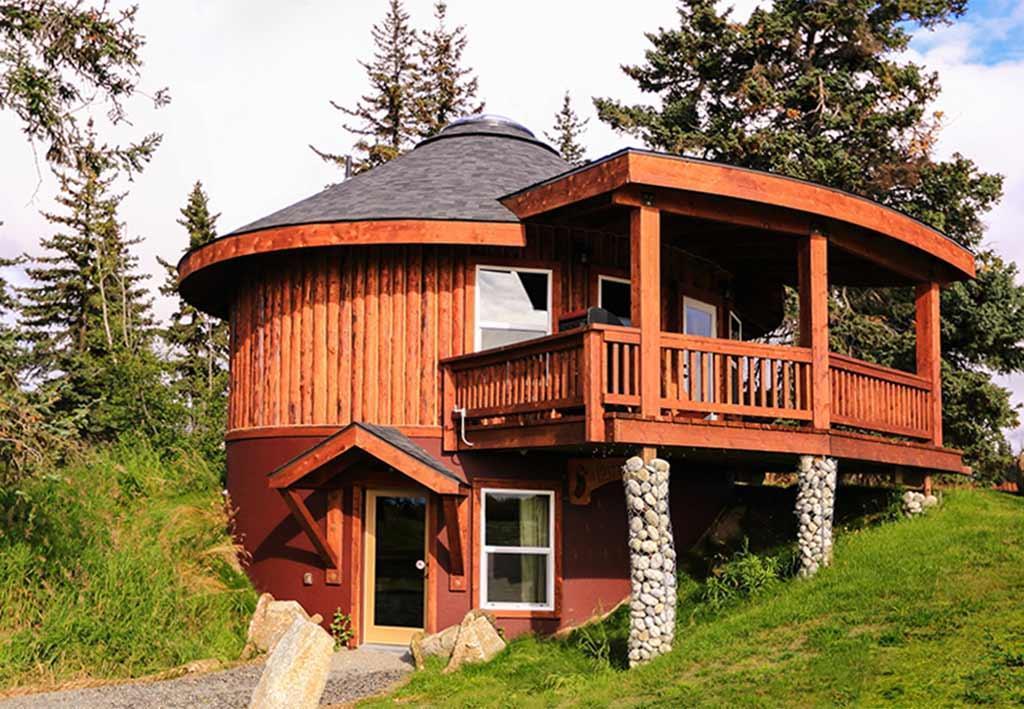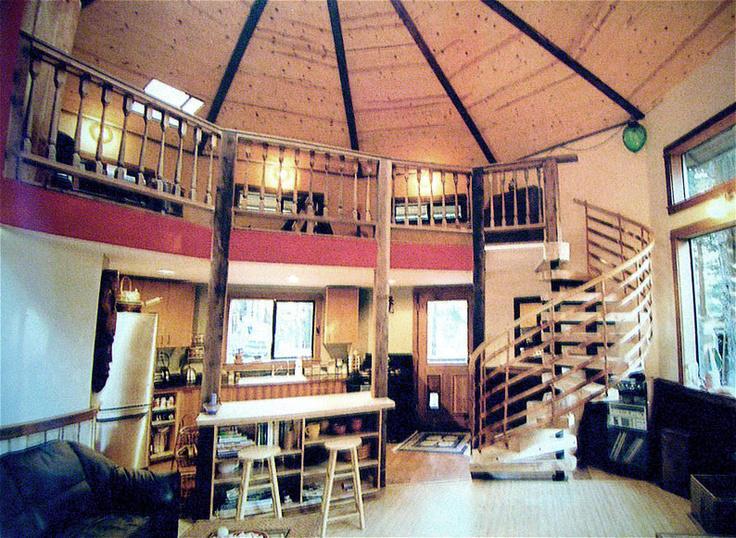The first image is the image on the left, the second image is the image on the right. Considering the images on both sides, is "One image is the exterior of a wooden yurt, while the second image is a yurt interior that shows a kitchen area and ribbed wooden ceiling." valid? Answer yes or no. Yes. The first image is the image on the left, the second image is the image on the right. Evaluate the accuracy of this statement regarding the images: "The exterior of a round building has a covered deck with a railing in front.". Is it true? Answer yes or no. Yes. 